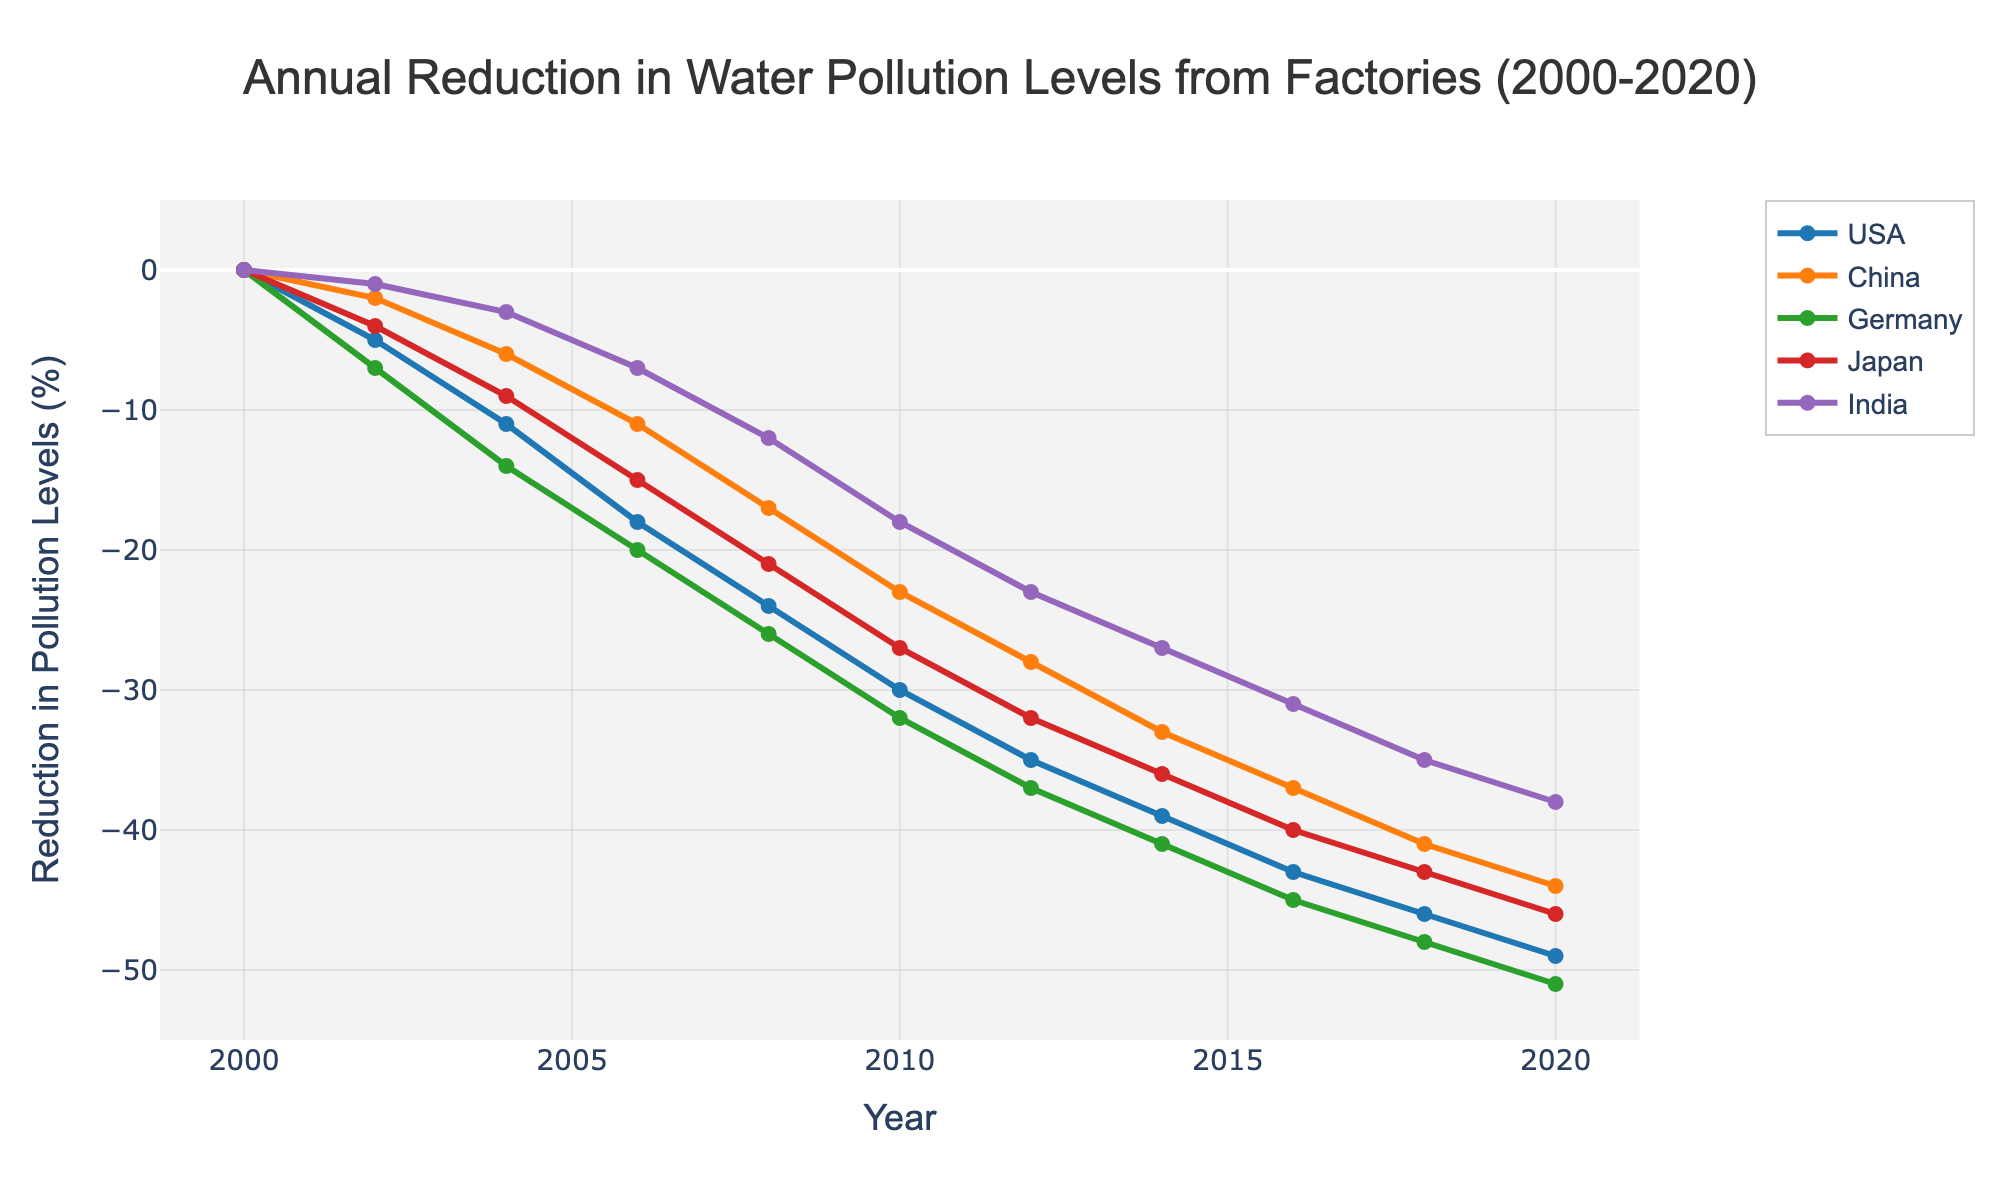What is the reduction in water pollution levels for the USA in the year 2010? Look at the point corresponding to the USA on the chart for the year 2010. The reduction in water pollution levels is indicated on the y-axis.
Answer: -30% Which country had the greatest reduction in water pollution levels in 2020? Compare the end points for each country in the year 2020. The country with the most negative value has the greatest reduction.
Answer: USA By how much did water pollution levels reduce in China from 2006 to 2008? Check the values for China in 2006 and 2008, then calculate the difference: -17 - (-11).
Answer: -6% Which country had the least reduction in water pollution levels in the year 2014? Compare the values of all five countries for the year 2014. The country with the smallest reduction (least negative value) is India.
Answer: India On average, how much did water pollution levels reduce annually in Japan between 2004 and 2014? Find the reduction values for Japan from 2004 to 2014, sum them, and then divide by the number of years (14 - 4 = 10 years). The reduction values are -9, -15, -21, -27, -32, -36. The sum is -140. The average annual reduction is -140 / 10.
Answer: -14% What is the difference in the reduction of water pollution levels between Germany and India in 2012? Check the values for Germany and India in 2012 and subtract India's reduction from Germany's reduction: -37 - (-23).
Answer: -14% Which country shows the most consistent reduction in water pollution levels over the years? Look at the trend lines for each country. The country with the smoothest and most linear reduction curve is Germany.
Answer: Germany How does the water pollution reduction in Japan compare between 2004 and 2020? Compare the values for Japan in 2004 and 2020. Find the difference: -46 - (-9).
Answer: -37% By what percentage did the water pollution levels decrease in India from 2000 to 2020? Subtract India's reduction in 2000 from the reduction in 2020. Calculate the decrease from 0 to -38.
Answer: 38% Which country had a faster reduction rate from 2006 to 2016, USA or China? Calculate the decrease for both countries from 2006 to 2016. For the USA, the reduction is -43 - (-18) = -25. For China, the reduction is -37 - (-11) = -26. Compare the absolute values to find the faster reduction rate.
Answer: China 